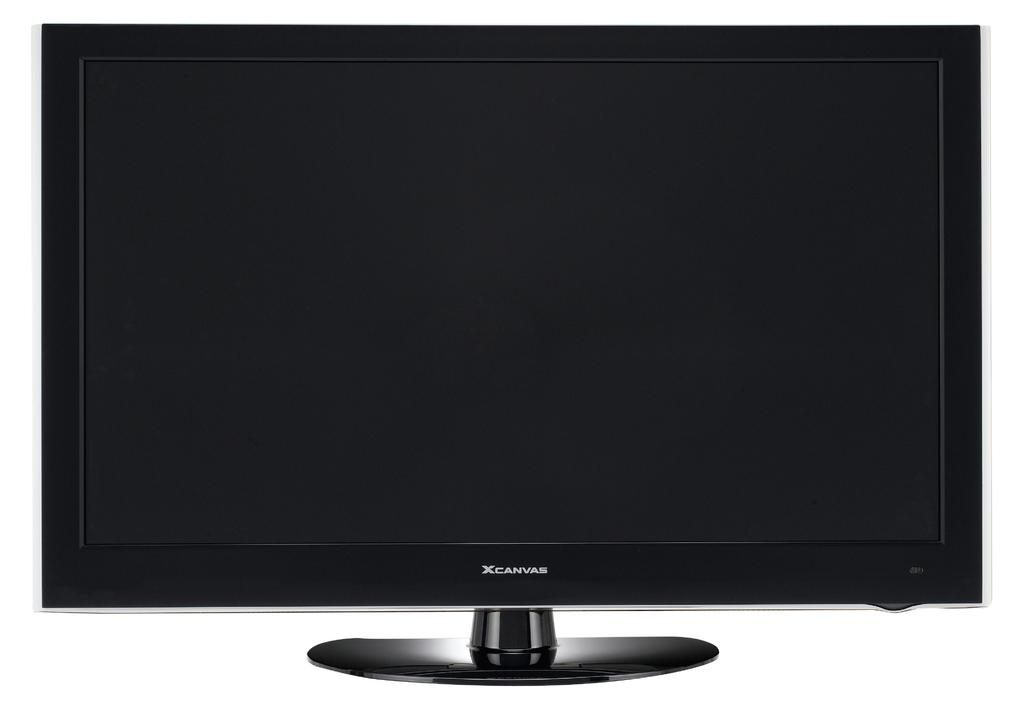<image>
Create a compact narrative representing the image presented. A computer monitor that says Xcanvas on the bottom. 